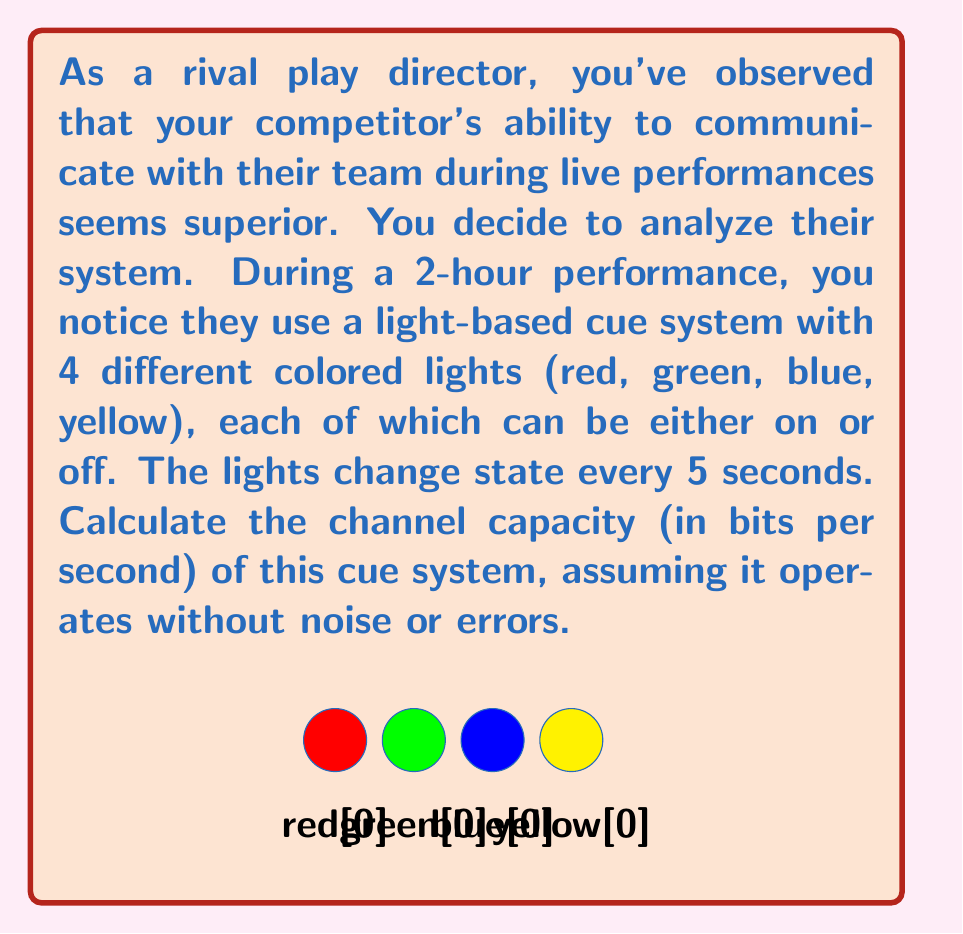Could you help me with this problem? Let's approach this step-by-step:

1) First, we need to determine the number of possible states in the system:
   - There are 4 lights, each can be on or off
   - This gives us $2^4 = 16$ possible states

2) Now, let's calculate how many times the state can change during the performance:
   - The performance lasts 2 hours = 120 minutes = 7200 seconds
   - The state changes every 5 seconds
   - Number of state changes = 7200 / 5 = 1440

3) Each state change can be considered a symbol in our communication system

4) The channel capacity formula is:
   $C = R \log_2 M$
   Where:
   $C$ = channel capacity in bits per second
   $R$ = symbol rate (symbols per second)
   $M$ = number of distinct symbols

5) In our case:
   $R = 1/5$ symbols per second (as the state changes every 5 seconds)
   $M = 16$ (the number of possible states)

6) Plugging into the formula:
   $C = \frac{1}{5} \log_2 16$

7) Simplify:
   $C = \frac{1}{5} \cdot 4 = 0.8$ bits per second

Thus, the channel capacity of this cue system is 0.8 bits per second.
Answer: 0.8 bits/second 